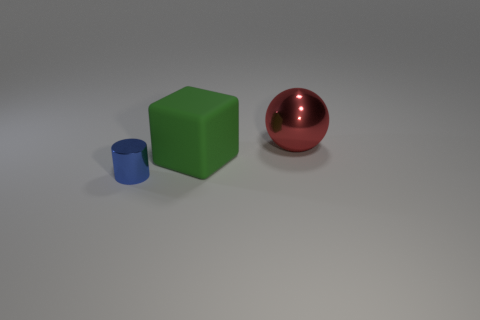Are there the same number of large green matte objects to the left of the large green block and small metal things behind the red sphere?
Keep it short and to the point. Yes. There is a metal thing that is left of the shiny object that is on the right side of the small blue metallic object; what size is it?
Provide a short and direct response. Small. There is a object that is both right of the blue cylinder and in front of the large red sphere; what material is it?
Make the answer very short. Rubber. What number of other objects are there of the same size as the rubber block?
Offer a terse response. 1. The rubber cube has what color?
Provide a short and direct response. Green. Is the color of the shiny object that is behind the tiny blue cylinder the same as the object in front of the big green thing?
Keep it short and to the point. No. What is the size of the shiny cylinder?
Give a very brief answer. Small. There is a metal object to the left of the red metallic ball; how big is it?
Offer a terse response. Small. What number of other things are the same shape as the big green rubber thing?
Ensure brevity in your answer.  0. The object that is the same size as the green rubber block is what color?
Give a very brief answer. Red. 